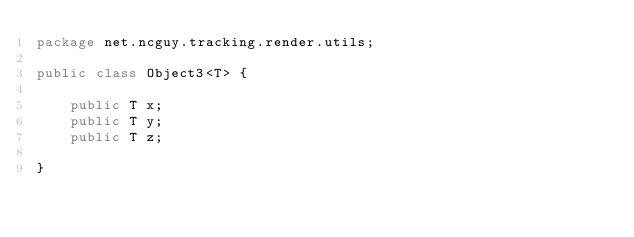Convert code to text. <code><loc_0><loc_0><loc_500><loc_500><_Java_>package net.ncguy.tracking.render.utils;

public class Object3<T> {

    public T x;
    public T y;
    public T z;

}
</code> 